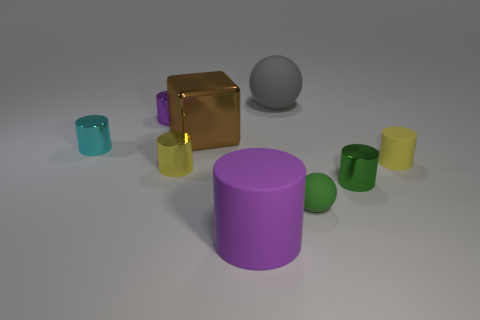How many things are large yellow cylinders or matte things right of the big purple matte object?
Make the answer very short. 3. There is a purple object that is made of the same material as the tiny sphere; what is its size?
Your answer should be compact. Large. There is a purple object that is left of the yellow object that is to the left of the yellow rubber object; what is its shape?
Provide a succinct answer. Cylinder. What size is the cylinder that is in front of the yellow rubber object and on the right side of the big gray matte ball?
Offer a terse response. Small. Are there any other rubber things of the same shape as the tiny cyan thing?
Make the answer very short. Yes. Is there anything else that is the same shape as the brown thing?
Ensure brevity in your answer.  No. The purple thing behind the purple cylinder that is in front of the small yellow thing that is on the right side of the tiny yellow metallic object is made of what material?
Keep it short and to the point. Metal. Are there any green cylinders that have the same size as the yellow metallic cylinder?
Provide a short and direct response. Yes. There is a ball behind the yellow cylinder that is on the left side of the big gray rubber thing; what is its color?
Give a very brief answer. Gray. How many large purple matte things are there?
Provide a short and direct response. 1. 